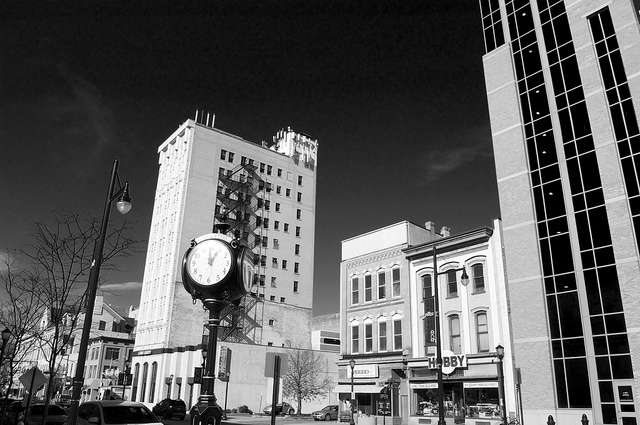Describe the objects in this image and their specific colors. I can see clock in black, white, darkgray, and gray tones, car in black, gray, darkgray, and lightgray tones, car in black and gray tones, car in black, gray, darkgray, and lightgray tones, and car in black, gray, darkgray, and lightgray tones in this image. 